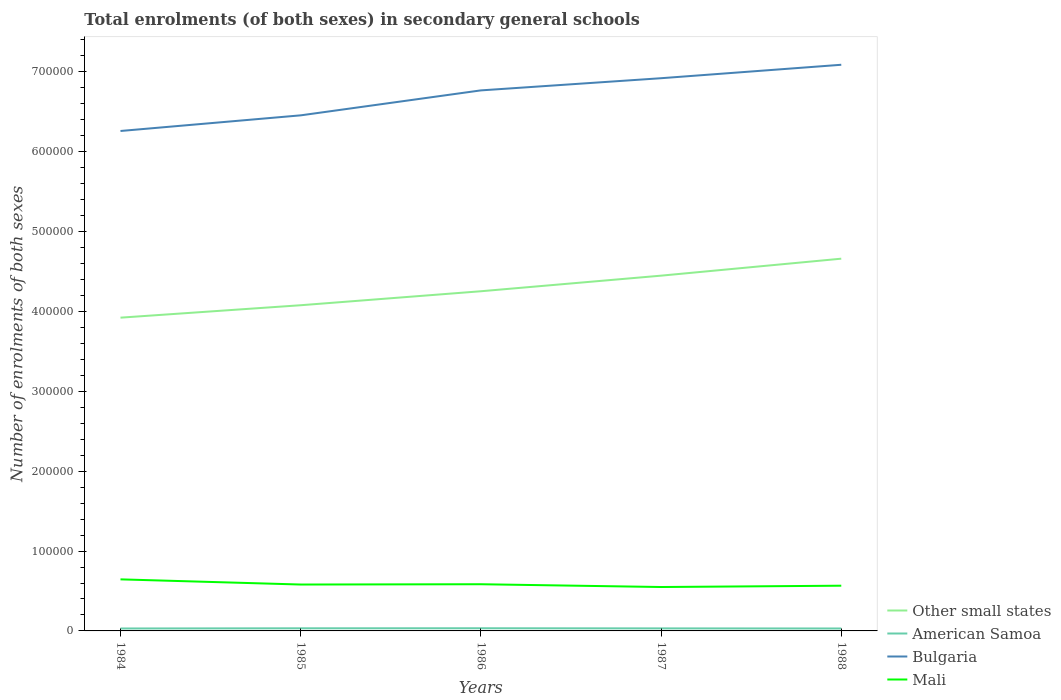How many different coloured lines are there?
Offer a terse response. 4. Does the line corresponding to American Samoa intersect with the line corresponding to Bulgaria?
Offer a very short reply. No. Across all years, what is the maximum number of enrolments in secondary schools in American Samoa?
Provide a succinct answer. 3051. In which year was the number of enrolments in secondary schools in American Samoa maximum?
Offer a terse response. 1984. What is the total number of enrolments in secondary schools in Mali in the graph?
Keep it short and to the point. 6117. What is the difference between the highest and the second highest number of enrolments in secondary schools in American Samoa?
Keep it short and to the point. 291. What is the difference between the highest and the lowest number of enrolments in secondary schools in American Samoa?
Offer a very short reply. 2. How many lines are there?
Provide a short and direct response. 4. What is the difference between two consecutive major ticks on the Y-axis?
Offer a terse response. 1.00e+05. Are the values on the major ticks of Y-axis written in scientific E-notation?
Provide a succinct answer. No. Does the graph contain any zero values?
Ensure brevity in your answer.  No. Does the graph contain grids?
Give a very brief answer. No. How many legend labels are there?
Keep it short and to the point. 4. What is the title of the graph?
Your response must be concise. Total enrolments (of both sexes) in secondary general schools. What is the label or title of the X-axis?
Your response must be concise. Years. What is the label or title of the Y-axis?
Keep it short and to the point. Number of enrolments of both sexes. What is the Number of enrolments of both sexes of Other small states in 1984?
Provide a succinct answer. 3.92e+05. What is the Number of enrolments of both sexes in American Samoa in 1984?
Offer a terse response. 3051. What is the Number of enrolments of both sexes of Bulgaria in 1984?
Your answer should be very brief. 6.26e+05. What is the Number of enrolments of both sexes of Mali in 1984?
Your answer should be compact. 6.46e+04. What is the Number of enrolments of both sexes of Other small states in 1985?
Your response must be concise. 4.08e+05. What is the Number of enrolments of both sexes of American Samoa in 1985?
Your answer should be compact. 3287. What is the Number of enrolments of both sexes in Bulgaria in 1985?
Ensure brevity in your answer.  6.46e+05. What is the Number of enrolments of both sexes in Mali in 1985?
Offer a terse response. 5.81e+04. What is the Number of enrolments of both sexes in Other small states in 1986?
Offer a very short reply. 4.25e+05. What is the Number of enrolments of both sexes in American Samoa in 1986?
Provide a short and direct response. 3342. What is the Number of enrolments of both sexes of Bulgaria in 1986?
Your answer should be very brief. 6.77e+05. What is the Number of enrolments of both sexes in Mali in 1986?
Offer a very short reply. 5.84e+04. What is the Number of enrolments of both sexes of Other small states in 1987?
Offer a terse response. 4.45e+05. What is the Number of enrolments of both sexes of American Samoa in 1987?
Your answer should be compact. 3171. What is the Number of enrolments of both sexes in Bulgaria in 1987?
Your answer should be very brief. 6.92e+05. What is the Number of enrolments of both sexes of Mali in 1987?
Give a very brief answer. 5.50e+04. What is the Number of enrolments of both sexes in Other small states in 1988?
Ensure brevity in your answer.  4.66e+05. What is the Number of enrolments of both sexes in American Samoa in 1988?
Your response must be concise. 3053. What is the Number of enrolments of both sexes in Bulgaria in 1988?
Your answer should be compact. 7.09e+05. What is the Number of enrolments of both sexes of Mali in 1988?
Ensure brevity in your answer.  5.66e+04. Across all years, what is the maximum Number of enrolments of both sexes in Other small states?
Give a very brief answer. 4.66e+05. Across all years, what is the maximum Number of enrolments of both sexes in American Samoa?
Keep it short and to the point. 3342. Across all years, what is the maximum Number of enrolments of both sexes of Bulgaria?
Provide a succinct answer. 7.09e+05. Across all years, what is the maximum Number of enrolments of both sexes in Mali?
Make the answer very short. 6.46e+04. Across all years, what is the minimum Number of enrolments of both sexes in Other small states?
Offer a terse response. 3.92e+05. Across all years, what is the minimum Number of enrolments of both sexes of American Samoa?
Provide a short and direct response. 3051. Across all years, what is the minimum Number of enrolments of both sexes of Bulgaria?
Ensure brevity in your answer.  6.26e+05. Across all years, what is the minimum Number of enrolments of both sexes of Mali?
Keep it short and to the point. 5.50e+04. What is the total Number of enrolments of both sexes in Other small states in the graph?
Ensure brevity in your answer.  2.14e+06. What is the total Number of enrolments of both sexes of American Samoa in the graph?
Provide a short and direct response. 1.59e+04. What is the total Number of enrolments of both sexes of Bulgaria in the graph?
Give a very brief answer. 3.35e+06. What is the total Number of enrolments of both sexes in Mali in the graph?
Ensure brevity in your answer.  2.93e+05. What is the difference between the Number of enrolments of both sexes in Other small states in 1984 and that in 1985?
Make the answer very short. -1.55e+04. What is the difference between the Number of enrolments of both sexes of American Samoa in 1984 and that in 1985?
Provide a succinct answer. -236. What is the difference between the Number of enrolments of both sexes in Bulgaria in 1984 and that in 1985?
Your response must be concise. -1.96e+04. What is the difference between the Number of enrolments of both sexes in Mali in 1984 and that in 1985?
Provide a succinct answer. 6487. What is the difference between the Number of enrolments of both sexes of Other small states in 1984 and that in 1986?
Ensure brevity in your answer.  -3.31e+04. What is the difference between the Number of enrolments of both sexes in American Samoa in 1984 and that in 1986?
Provide a short and direct response. -291. What is the difference between the Number of enrolments of both sexes in Bulgaria in 1984 and that in 1986?
Provide a short and direct response. -5.08e+04. What is the difference between the Number of enrolments of both sexes in Mali in 1984 and that in 1986?
Offer a very short reply. 6117. What is the difference between the Number of enrolments of both sexes in Other small states in 1984 and that in 1987?
Offer a very short reply. -5.26e+04. What is the difference between the Number of enrolments of both sexes in American Samoa in 1984 and that in 1987?
Your response must be concise. -120. What is the difference between the Number of enrolments of both sexes of Bulgaria in 1984 and that in 1987?
Make the answer very short. -6.61e+04. What is the difference between the Number of enrolments of both sexes in Mali in 1984 and that in 1987?
Make the answer very short. 9598. What is the difference between the Number of enrolments of both sexes in Other small states in 1984 and that in 1988?
Your response must be concise. -7.38e+04. What is the difference between the Number of enrolments of both sexes of American Samoa in 1984 and that in 1988?
Make the answer very short. -2. What is the difference between the Number of enrolments of both sexes of Bulgaria in 1984 and that in 1988?
Make the answer very short. -8.29e+04. What is the difference between the Number of enrolments of both sexes of Mali in 1984 and that in 1988?
Offer a very short reply. 7944. What is the difference between the Number of enrolments of both sexes of Other small states in 1985 and that in 1986?
Keep it short and to the point. -1.75e+04. What is the difference between the Number of enrolments of both sexes of American Samoa in 1985 and that in 1986?
Make the answer very short. -55. What is the difference between the Number of enrolments of both sexes of Bulgaria in 1985 and that in 1986?
Give a very brief answer. -3.13e+04. What is the difference between the Number of enrolments of both sexes in Mali in 1985 and that in 1986?
Provide a succinct answer. -370. What is the difference between the Number of enrolments of both sexes of Other small states in 1985 and that in 1987?
Keep it short and to the point. -3.70e+04. What is the difference between the Number of enrolments of both sexes in American Samoa in 1985 and that in 1987?
Provide a succinct answer. 116. What is the difference between the Number of enrolments of both sexes of Bulgaria in 1985 and that in 1987?
Your answer should be compact. -4.65e+04. What is the difference between the Number of enrolments of both sexes in Mali in 1985 and that in 1987?
Provide a short and direct response. 3111. What is the difference between the Number of enrolments of both sexes in Other small states in 1985 and that in 1988?
Your answer should be compact. -5.83e+04. What is the difference between the Number of enrolments of both sexes of American Samoa in 1985 and that in 1988?
Offer a very short reply. 234. What is the difference between the Number of enrolments of both sexes of Bulgaria in 1985 and that in 1988?
Provide a short and direct response. -6.33e+04. What is the difference between the Number of enrolments of both sexes in Mali in 1985 and that in 1988?
Make the answer very short. 1457. What is the difference between the Number of enrolments of both sexes in Other small states in 1986 and that in 1987?
Keep it short and to the point. -1.95e+04. What is the difference between the Number of enrolments of both sexes of American Samoa in 1986 and that in 1987?
Offer a terse response. 171. What is the difference between the Number of enrolments of both sexes of Bulgaria in 1986 and that in 1987?
Offer a very short reply. -1.52e+04. What is the difference between the Number of enrolments of both sexes in Mali in 1986 and that in 1987?
Your answer should be compact. 3481. What is the difference between the Number of enrolments of both sexes of Other small states in 1986 and that in 1988?
Your response must be concise. -4.08e+04. What is the difference between the Number of enrolments of both sexes in American Samoa in 1986 and that in 1988?
Your answer should be very brief. 289. What is the difference between the Number of enrolments of both sexes in Bulgaria in 1986 and that in 1988?
Ensure brevity in your answer.  -3.21e+04. What is the difference between the Number of enrolments of both sexes of Mali in 1986 and that in 1988?
Provide a short and direct response. 1827. What is the difference between the Number of enrolments of both sexes in Other small states in 1987 and that in 1988?
Your answer should be compact. -2.13e+04. What is the difference between the Number of enrolments of both sexes of American Samoa in 1987 and that in 1988?
Provide a succinct answer. 118. What is the difference between the Number of enrolments of both sexes of Bulgaria in 1987 and that in 1988?
Provide a succinct answer. -1.68e+04. What is the difference between the Number of enrolments of both sexes of Mali in 1987 and that in 1988?
Make the answer very short. -1654. What is the difference between the Number of enrolments of both sexes in Other small states in 1984 and the Number of enrolments of both sexes in American Samoa in 1985?
Give a very brief answer. 3.89e+05. What is the difference between the Number of enrolments of both sexes in Other small states in 1984 and the Number of enrolments of both sexes in Bulgaria in 1985?
Your answer should be compact. -2.53e+05. What is the difference between the Number of enrolments of both sexes of Other small states in 1984 and the Number of enrolments of both sexes of Mali in 1985?
Keep it short and to the point. 3.34e+05. What is the difference between the Number of enrolments of both sexes in American Samoa in 1984 and the Number of enrolments of both sexes in Bulgaria in 1985?
Provide a succinct answer. -6.42e+05. What is the difference between the Number of enrolments of both sexes of American Samoa in 1984 and the Number of enrolments of both sexes of Mali in 1985?
Your answer should be compact. -5.50e+04. What is the difference between the Number of enrolments of both sexes of Bulgaria in 1984 and the Number of enrolments of both sexes of Mali in 1985?
Provide a succinct answer. 5.68e+05. What is the difference between the Number of enrolments of both sexes of Other small states in 1984 and the Number of enrolments of both sexes of American Samoa in 1986?
Give a very brief answer. 3.89e+05. What is the difference between the Number of enrolments of both sexes in Other small states in 1984 and the Number of enrolments of both sexes in Bulgaria in 1986?
Provide a short and direct response. -2.85e+05. What is the difference between the Number of enrolments of both sexes of Other small states in 1984 and the Number of enrolments of both sexes of Mali in 1986?
Offer a terse response. 3.34e+05. What is the difference between the Number of enrolments of both sexes in American Samoa in 1984 and the Number of enrolments of both sexes in Bulgaria in 1986?
Make the answer very short. -6.74e+05. What is the difference between the Number of enrolments of both sexes in American Samoa in 1984 and the Number of enrolments of both sexes in Mali in 1986?
Your answer should be compact. -5.54e+04. What is the difference between the Number of enrolments of both sexes in Bulgaria in 1984 and the Number of enrolments of both sexes in Mali in 1986?
Your answer should be very brief. 5.68e+05. What is the difference between the Number of enrolments of both sexes of Other small states in 1984 and the Number of enrolments of both sexes of American Samoa in 1987?
Provide a succinct answer. 3.89e+05. What is the difference between the Number of enrolments of both sexes of Other small states in 1984 and the Number of enrolments of both sexes of Bulgaria in 1987?
Your answer should be compact. -3.00e+05. What is the difference between the Number of enrolments of both sexes in Other small states in 1984 and the Number of enrolments of both sexes in Mali in 1987?
Your response must be concise. 3.37e+05. What is the difference between the Number of enrolments of both sexes in American Samoa in 1984 and the Number of enrolments of both sexes in Bulgaria in 1987?
Offer a terse response. -6.89e+05. What is the difference between the Number of enrolments of both sexes in American Samoa in 1984 and the Number of enrolments of both sexes in Mali in 1987?
Provide a succinct answer. -5.19e+04. What is the difference between the Number of enrolments of both sexes in Bulgaria in 1984 and the Number of enrolments of both sexes in Mali in 1987?
Provide a short and direct response. 5.71e+05. What is the difference between the Number of enrolments of both sexes of Other small states in 1984 and the Number of enrolments of both sexes of American Samoa in 1988?
Provide a short and direct response. 3.89e+05. What is the difference between the Number of enrolments of both sexes in Other small states in 1984 and the Number of enrolments of both sexes in Bulgaria in 1988?
Offer a terse response. -3.17e+05. What is the difference between the Number of enrolments of both sexes of Other small states in 1984 and the Number of enrolments of both sexes of Mali in 1988?
Provide a short and direct response. 3.36e+05. What is the difference between the Number of enrolments of both sexes of American Samoa in 1984 and the Number of enrolments of both sexes of Bulgaria in 1988?
Your answer should be compact. -7.06e+05. What is the difference between the Number of enrolments of both sexes of American Samoa in 1984 and the Number of enrolments of both sexes of Mali in 1988?
Your response must be concise. -5.36e+04. What is the difference between the Number of enrolments of both sexes of Bulgaria in 1984 and the Number of enrolments of both sexes of Mali in 1988?
Keep it short and to the point. 5.69e+05. What is the difference between the Number of enrolments of both sexes in Other small states in 1985 and the Number of enrolments of both sexes in American Samoa in 1986?
Provide a short and direct response. 4.04e+05. What is the difference between the Number of enrolments of both sexes of Other small states in 1985 and the Number of enrolments of both sexes of Bulgaria in 1986?
Your answer should be compact. -2.69e+05. What is the difference between the Number of enrolments of both sexes in Other small states in 1985 and the Number of enrolments of both sexes in Mali in 1986?
Provide a succinct answer. 3.49e+05. What is the difference between the Number of enrolments of both sexes in American Samoa in 1985 and the Number of enrolments of both sexes in Bulgaria in 1986?
Offer a terse response. -6.73e+05. What is the difference between the Number of enrolments of both sexes of American Samoa in 1985 and the Number of enrolments of both sexes of Mali in 1986?
Provide a succinct answer. -5.52e+04. What is the difference between the Number of enrolments of both sexes in Bulgaria in 1985 and the Number of enrolments of both sexes in Mali in 1986?
Provide a short and direct response. 5.87e+05. What is the difference between the Number of enrolments of both sexes in Other small states in 1985 and the Number of enrolments of both sexes in American Samoa in 1987?
Offer a terse response. 4.05e+05. What is the difference between the Number of enrolments of both sexes in Other small states in 1985 and the Number of enrolments of both sexes in Bulgaria in 1987?
Ensure brevity in your answer.  -2.84e+05. What is the difference between the Number of enrolments of both sexes of Other small states in 1985 and the Number of enrolments of both sexes of Mali in 1987?
Ensure brevity in your answer.  3.53e+05. What is the difference between the Number of enrolments of both sexes in American Samoa in 1985 and the Number of enrolments of both sexes in Bulgaria in 1987?
Make the answer very short. -6.89e+05. What is the difference between the Number of enrolments of both sexes in American Samoa in 1985 and the Number of enrolments of both sexes in Mali in 1987?
Your answer should be compact. -5.17e+04. What is the difference between the Number of enrolments of both sexes in Bulgaria in 1985 and the Number of enrolments of both sexes in Mali in 1987?
Your answer should be very brief. 5.91e+05. What is the difference between the Number of enrolments of both sexes of Other small states in 1985 and the Number of enrolments of both sexes of American Samoa in 1988?
Ensure brevity in your answer.  4.05e+05. What is the difference between the Number of enrolments of both sexes of Other small states in 1985 and the Number of enrolments of both sexes of Bulgaria in 1988?
Ensure brevity in your answer.  -3.01e+05. What is the difference between the Number of enrolments of both sexes in Other small states in 1985 and the Number of enrolments of both sexes in Mali in 1988?
Your answer should be compact. 3.51e+05. What is the difference between the Number of enrolments of both sexes in American Samoa in 1985 and the Number of enrolments of both sexes in Bulgaria in 1988?
Offer a very short reply. -7.06e+05. What is the difference between the Number of enrolments of both sexes of American Samoa in 1985 and the Number of enrolments of both sexes of Mali in 1988?
Offer a very short reply. -5.33e+04. What is the difference between the Number of enrolments of both sexes of Bulgaria in 1985 and the Number of enrolments of both sexes of Mali in 1988?
Ensure brevity in your answer.  5.89e+05. What is the difference between the Number of enrolments of both sexes of Other small states in 1986 and the Number of enrolments of both sexes of American Samoa in 1987?
Offer a very short reply. 4.22e+05. What is the difference between the Number of enrolments of both sexes of Other small states in 1986 and the Number of enrolments of both sexes of Bulgaria in 1987?
Your answer should be very brief. -2.67e+05. What is the difference between the Number of enrolments of both sexes in Other small states in 1986 and the Number of enrolments of both sexes in Mali in 1987?
Give a very brief answer. 3.70e+05. What is the difference between the Number of enrolments of both sexes of American Samoa in 1986 and the Number of enrolments of both sexes of Bulgaria in 1987?
Provide a succinct answer. -6.89e+05. What is the difference between the Number of enrolments of both sexes of American Samoa in 1986 and the Number of enrolments of both sexes of Mali in 1987?
Offer a very short reply. -5.16e+04. What is the difference between the Number of enrolments of both sexes in Bulgaria in 1986 and the Number of enrolments of both sexes in Mali in 1987?
Provide a short and direct response. 6.22e+05. What is the difference between the Number of enrolments of both sexes of Other small states in 1986 and the Number of enrolments of both sexes of American Samoa in 1988?
Give a very brief answer. 4.22e+05. What is the difference between the Number of enrolments of both sexes in Other small states in 1986 and the Number of enrolments of both sexes in Bulgaria in 1988?
Your answer should be very brief. -2.84e+05. What is the difference between the Number of enrolments of both sexes of Other small states in 1986 and the Number of enrolments of both sexes of Mali in 1988?
Your response must be concise. 3.69e+05. What is the difference between the Number of enrolments of both sexes in American Samoa in 1986 and the Number of enrolments of both sexes in Bulgaria in 1988?
Your answer should be very brief. -7.06e+05. What is the difference between the Number of enrolments of both sexes in American Samoa in 1986 and the Number of enrolments of both sexes in Mali in 1988?
Offer a very short reply. -5.33e+04. What is the difference between the Number of enrolments of both sexes of Bulgaria in 1986 and the Number of enrolments of both sexes of Mali in 1988?
Offer a very short reply. 6.20e+05. What is the difference between the Number of enrolments of both sexes of Other small states in 1987 and the Number of enrolments of both sexes of American Samoa in 1988?
Your answer should be very brief. 4.42e+05. What is the difference between the Number of enrolments of both sexes of Other small states in 1987 and the Number of enrolments of both sexes of Bulgaria in 1988?
Ensure brevity in your answer.  -2.64e+05. What is the difference between the Number of enrolments of both sexes of Other small states in 1987 and the Number of enrolments of both sexes of Mali in 1988?
Provide a short and direct response. 3.88e+05. What is the difference between the Number of enrolments of both sexes in American Samoa in 1987 and the Number of enrolments of both sexes in Bulgaria in 1988?
Ensure brevity in your answer.  -7.06e+05. What is the difference between the Number of enrolments of both sexes in American Samoa in 1987 and the Number of enrolments of both sexes in Mali in 1988?
Give a very brief answer. -5.34e+04. What is the difference between the Number of enrolments of both sexes of Bulgaria in 1987 and the Number of enrolments of both sexes of Mali in 1988?
Your response must be concise. 6.35e+05. What is the average Number of enrolments of both sexes of Other small states per year?
Offer a terse response. 4.27e+05. What is the average Number of enrolments of both sexes in American Samoa per year?
Your answer should be compact. 3180.8. What is the average Number of enrolments of both sexes in Bulgaria per year?
Your response must be concise. 6.70e+05. What is the average Number of enrolments of both sexes of Mali per year?
Offer a terse response. 5.85e+04. In the year 1984, what is the difference between the Number of enrolments of both sexes in Other small states and Number of enrolments of both sexes in American Samoa?
Ensure brevity in your answer.  3.89e+05. In the year 1984, what is the difference between the Number of enrolments of both sexes of Other small states and Number of enrolments of both sexes of Bulgaria?
Give a very brief answer. -2.34e+05. In the year 1984, what is the difference between the Number of enrolments of both sexes of Other small states and Number of enrolments of both sexes of Mali?
Your response must be concise. 3.28e+05. In the year 1984, what is the difference between the Number of enrolments of both sexes of American Samoa and Number of enrolments of both sexes of Bulgaria?
Make the answer very short. -6.23e+05. In the year 1984, what is the difference between the Number of enrolments of both sexes of American Samoa and Number of enrolments of both sexes of Mali?
Your response must be concise. -6.15e+04. In the year 1984, what is the difference between the Number of enrolments of both sexes in Bulgaria and Number of enrolments of both sexes in Mali?
Your answer should be very brief. 5.61e+05. In the year 1985, what is the difference between the Number of enrolments of both sexes in Other small states and Number of enrolments of both sexes in American Samoa?
Your answer should be compact. 4.04e+05. In the year 1985, what is the difference between the Number of enrolments of both sexes in Other small states and Number of enrolments of both sexes in Bulgaria?
Provide a short and direct response. -2.38e+05. In the year 1985, what is the difference between the Number of enrolments of both sexes of Other small states and Number of enrolments of both sexes of Mali?
Keep it short and to the point. 3.50e+05. In the year 1985, what is the difference between the Number of enrolments of both sexes of American Samoa and Number of enrolments of both sexes of Bulgaria?
Offer a terse response. -6.42e+05. In the year 1985, what is the difference between the Number of enrolments of both sexes in American Samoa and Number of enrolments of both sexes in Mali?
Ensure brevity in your answer.  -5.48e+04. In the year 1985, what is the difference between the Number of enrolments of both sexes in Bulgaria and Number of enrolments of both sexes in Mali?
Offer a terse response. 5.87e+05. In the year 1986, what is the difference between the Number of enrolments of both sexes in Other small states and Number of enrolments of both sexes in American Samoa?
Offer a terse response. 4.22e+05. In the year 1986, what is the difference between the Number of enrolments of both sexes of Other small states and Number of enrolments of both sexes of Bulgaria?
Offer a very short reply. -2.51e+05. In the year 1986, what is the difference between the Number of enrolments of both sexes in Other small states and Number of enrolments of both sexes in Mali?
Give a very brief answer. 3.67e+05. In the year 1986, what is the difference between the Number of enrolments of both sexes of American Samoa and Number of enrolments of both sexes of Bulgaria?
Your answer should be very brief. -6.73e+05. In the year 1986, what is the difference between the Number of enrolments of both sexes of American Samoa and Number of enrolments of both sexes of Mali?
Provide a short and direct response. -5.51e+04. In the year 1986, what is the difference between the Number of enrolments of both sexes in Bulgaria and Number of enrolments of both sexes in Mali?
Provide a succinct answer. 6.18e+05. In the year 1987, what is the difference between the Number of enrolments of both sexes of Other small states and Number of enrolments of both sexes of American Samoa?
Keep it short and to the point. 4.42e+05. In the year 1987, what is the difference between the Number of enrolments of both sexes in Other small states and Number of enrolments of both sexes in Bulgaria?
Offer a very short reply. -2.47e+05. In the year 1987, what is the difference between the Number of enrolments of both sexes of Other small states and Number of enrolments of both sexes of Mali?
Offer a very short reply. 3.90e+05. In the year 1987, what is the difference between the Number of enrolments of both sexes in American Samoa and Number of enrolments of both sexes in Bulgaria?
Ensure brevity in your answer.  -6.89e+05. In the year 1987, what is the difference between the Number of enrolments of both sexes of American Samoa and Number of enrolments of both sexes of Mali?
Your answer should be compact. -5.18e+04. In the year 1987, what is the difference between the Number of enrolments of both sexes of Bulgaria and Number of enrolments of both sexes of Mali?
Your answer should be very brief. 6.37e+05. In the year 1988, what is the difference between the Number of enrolments of both sexes of Other small states and Number of enrolments of both sexes of American Samoa?
Your response must be concise. 4.63e+05. In the year 1988, what is the difference between the Number of enrolments of both sexes of Other small states and Number of enrolments of both sexes of Bulgaria?
Your response must be concise. -2.43e+05. In the year 1988, what is the difference between the Number of enrolments of both sexes of Other small states and Number of enrolments of both sexes of Mali?
Offer a terse response. 4.09e+05. In the year 1988, what is the difference between the Number of enrolments of both sexes of American Samoa and Number of enrolments of both sexes of Bulgaria?
Offer a terse response. -7.06e+05. In the year 1988, what is the difference between the Number of enrolments of both sexes of American Samoa and Number of enrolments of both sexes of Mali?
Your response must be concise. -5.36e+04. In the year 1988, what is the difference between the Number of enrolments of both sexes of Bulgaria and Number of enrolments of both sexes of Mali?
Your response must be concise. 6.52e+05. What is the ratio of the Number of enrolments of both sexes in Other small states in 1984 to that in 1985?
Offer a very short reply. 0.96. What is the ratio of the Number of enrolments of both sexes of American Samoa in 1984 to that in 1985?
Offer a terse response. 0.93. What is the ratio of the Number of enrolments of both sexes of Bulgaria in 1984 to that in 1985?
Provide a short and direct response. 0.97. What is the ratio of the Number of enrolments of both sexes of Mali in 1984 to that in 1985?
Offer a terse response. 1.11. What is the ratio of the Number of enrolments of both sexes of Other small states in 1984 to that in 1986?
Provide a succinct answer. 0.92. What is the ratio of the Number of enrolments of both sexes in American Samoa in 1984 to that in 1986?
Keep it short and to the point. 0.91. What is the ratio of the Number of enrolments of both sexes of Bulgaria in 1984 to that in 1986?
Offer a very short reply. 0.92. What is the ratio of the Number of enrolments of both sexes in Mali in 1984 to that in 1986?
Ensure brevity in your answer.  1.1. What is the ratio of the Number of enrolments of both sexes in Other small states in 1984 to that in 1987?
Provide a short and direct response. 0.88. What is the ratio of the Number of enrolments of both sexes of American Samoa in 1984 to that in 1987?
Your answer should be compact. 0.96. What is the ratio of the Number of enrolments of both sexes of Bulgaria in 1984 to that in 1987?
Your response must be concise. 0.9. What is the ratio of the Number of enrolments of both sexes of Mali in 1984 to that in 1987?
Make the answer very short. 1.17. What is the ratio of the Number of enrolments of both sexes in Other small states in 1984 to that in 1988?
Your answer should be compact. 0.84. What is the ratio of the Number of enrolments of both sexes in American Samoa in 1984 to that in 1988?
Your response must be concise. 1. What is the ratio of the Number of enrolments of both sexes of Bulgaria in 1984 to that in 1988?
Offer a very short reply. 0.88. What is the ratio of the Number of enrolments of both sexes of Mali in 1984 to that in 1988?
Provide a short and direct response. 1.14. What is the ratio of the Number of enrolments of both sexes of Other small states in 1985 to that in 1986?
Your answer should be very brief. 0.96. What is the ratio of the Number of enrolments of both sexes of American Samoa in 1985 to that in 1986?
Ensure brevity in your answer.  0.98. What is the ratio of the Number of enrolments of both sexes of Bulgaria in 1985 to that in 1986?
Provide a succinct answer. 0.95. What is the ratio of the Number of enrolments of both sexes in American Samoa in 1985 to that in 1987?
Provide a short and direct response. 1.04. What is the ratio of the Number of enrolments of both sexes of Bulgaria in 1985 to that in 1987?
Your answer should be very brief. 0.93. What is the ratio of the Number of enrolments of both sexes in Mali in 1985 to that in 1987?
Your response must be concise. 1.06. What is the ratio of the Number of enrolments of both sexes of Other small states in 1985 to that in 1988?
Give a very brief answer. 0.87. What is the ratio of the Number of enrolments of both sexes of American Samoa in 1985 to that in 1988?
Provide a succinct answer. 1.08. What is the ratio of the Number of enrolments of both sexes of Bulgaria in 1985 to that in 1988?
Offer a terse response. 0.91. What is the ratio of the Number of enrolments of both sexes of Mali in 1985 to that in 1988?
Offer a very short reply. 1.03. What is the ratio of the Number of enrolments of both sexes in Other small states in 1986 to that in 1987?
Make the answer very short. 0.96. What is the ratio of the Number of enrolments of both sexes in American Samoa in 1986 to that in 1987?
Offer a terse response. 1.05. What is the ratio of the Number of enrolments of both sexes in Bulgaria in 1986 to that in 1987?
Provide a succinct answer. 0.98. What is the ratio of the Number of enrolments of both sexes in Mali in 1986 to that in 1987?
Your answer should be compact. 1.06. What is the ratio of the Number of enrolments of both sexes of Other small states in 1986 to that in 1988?
Your response must be concise. 0.91. What is the ratio of the Number of enrolments of both sexes in American Samoa in 1986 to that in 1988?
Offer a terse response. 1.09. What is the ratio of the Number of enrolments of both sexes of Bulgaria in 1986 to that in 1988?
Your answer should be very brief. 0.95. What is the ratio of the Number of enrolments of both sexes in Mali in 1986 to that in 1988?
Ensure brevity in your answer.  1.03. What is the ratio of the Number of enrolments of both sexes in Other small states in 1987 to that in 1988?
Give a very brief answer. 0.95. What is the ratio of the Number of enrolments of both sexes of American Samoa in 1987 to that in 1988?
Offer a terse response. 1.04. What is the ratio of the Number of enrolments of both sexes in Bulgaria in 1987 to that in 1988?
Your response must be concise. 0.98. What is the ratio of the Number of enrolments of both sexes in Mali in 1987 to that in 1988?
Give a very brief answer. 0.97. What is the difference between the highest and the second highest Number of enrolments of both sexes of Other small states?
Provide a short and direct response. 2.13e+04. What is the difference between the highest and the second highest Number of enrolments of both sexes of Bulgaria?
Give a very brief answer. 1.68e+04. What is the difference between the highest and the second highest Number of enrolments of both sexes in Mali?
Provide a succinct answer. 6117. What is the difference between the highest and the lowest Number of enrolments of both sexes in Other small states?
Provide a succinct answer. 7.38e+04. What is the difference between the highest and the lowest Number of enrolments of both sexes in American Samoa?
Give a very brief answer. 291. What is the difference between the highest and the lowest Number of enrolments of both sexes in Bulgaria?
Provide a short and direct response. 8.29e+04. What is the difference between the highest and the lowest Number of enrolments of both sexes in Mali?
Offer a very short reply. 9598. 